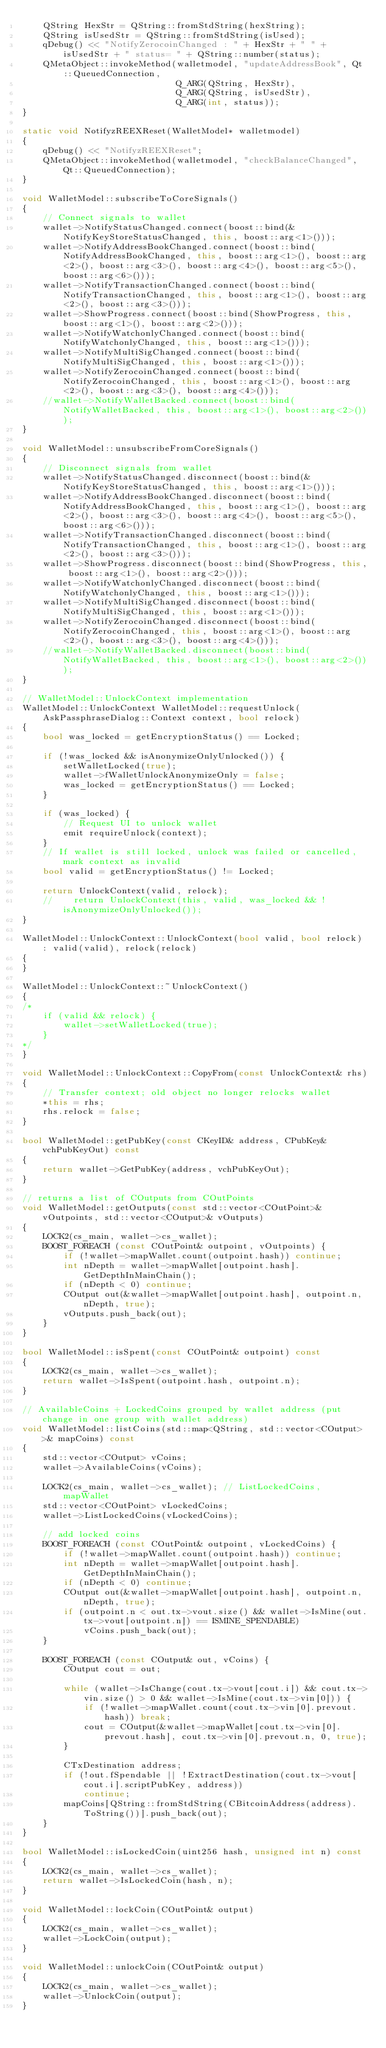Convert code to text. <code><loc_0><loc_0><loc_500><loc_500><_C++_>    QString HexStr = QString::fromStdString(hexString);
    QString isUsedStr = QString::fromStdString(isUsed);
    qDebug() << "NotifyZerocoinChanged : " + HexStr + " " + isUsedStr + " status= " + QString::number(status);
    QMetaObject::invokeMethod(walletmodel, "updateAddressBook", Qt::QueuedConnection,
                              Q_ARG(QString, HexStr),
                              Q_ARG(QString, isUsedStr),
                              Q_ARG(int, status));
}

static void NotifyzREEXReset(WalletModel* walletmodel)
{
    qDebug() << "NotifyzREEXReset";
    QMetaObject::invokeMethod(walletmodel, "checkBalanceChanged", Qt::QueuedConnection);
}

void WalletModel::subscribeToCoreSignals()
{
    // Connect signals to wallet
    wallet->NotifyStatusChanged.connect(boost::bind(&NotifyKeyStoreStatusChanged, this, boost::arg<1>()));
    wallet->NotifyAddressBookChanged.connect(boost::bind(NotifyAddressBookChanged, this, boost::arg<1>(), boost::arg<2>(), boost::arg<3>(), boost::arg<4>(), boost::arg<5>(), boost::arg<6>()));
    wallet->NotifyTransactionChanged.connect(boost::bind(NotifyTransactionChanged, this, boost::arg<1>(), boost::arg<2>(), boost::arg<3>()));
    wallet->ShowProgress.connect(boost::bind(ShowProgress, this, boost::arg<1>(), boost::arg<2>()));
    wallet->NotifyWatchonlyChanged.connect(boost::bind(NotifyWatchonlyChanged, this, boost::arg<1>()));
    wallet->NotifyMultiSigChanged.connect(boost::bind(NotifyMultiSigChanged, this, boost::arg<1>()));
    wallet->NotifyZerocoinChanged.connect(boost::bind(NotifyZerocoinChanged, this, boost::arg<1>(), boost::arg<2>(), boost::arg<3>(), boost::arg<4>()));
    //wallet->NotifyWalletBacked.connect(boost::bind(NotifyWalletBacked, this, boost::arg<1>(), boost::arg<2>()));
}

void WalletModel::unsubscribeFromCoreSignals()
{
    // Disconnect signals from wallet
    wallet->NotifyStatusChanged.disconnect(boost::bind(&NotifyKeyStoreStatusChanged, this, boost::arg<1>()));
    wallet->NotifyAddressBookChanged.disconnect(boost::bind(NotifyAddressBookChanged, this, boost::arg<1>(), boost::arg<2>(), boost::arg<3>(), boost::arg<4>(), boost::arg<5>(), boost::arg<6>()));
    wallet->NotifyTransactionChanged.disconnect(boost::bind(NotifyTransactionChanged, this, boost::arg<1>(), boost::arg<2>(), boost::arg<3>()));
    wallet->ShowProgress.disconnect(boost::bind(ShowProgress, this, boost::arg<1>(), boost::arg<2>()));
    wallet->NotifyWatchonlyChanged.disconnect(boost::bind(NotifyWatchonlyChanged, this, boost::arg<1>()));
    wallet->NotifyMultiSigChanged.disconnect(boost::bind(NotifyMultiSigChanged, this, boost::arg<1>()));
    wallet->NotifyZerocoinChanged.disconnect(boost::bind(NotifyZerocoinChanged, this, boost::arg<1>(), boost::arg<2>(), boost::arg<3>(), boost::arg<4>()));
    //wallet->NotifyWalletBacked.disconnect(boost::bind(NotifyWalletBacked, this, boost::arg<1>(), boost::arg<2>()));
}

// WalletModel::UnlockContext implementation
WalletModel::UnlockContext WalletModel::requestUnlock(AskPassphraseDialog::Context context, bool relock)
{
    bool was_locked = getEncryptionStatus() == Locked;

    if (!was_locked && isAnonymizeOnlyUnlocked()) {
        setWalletLocked(true);
        wallet->fWalletUnlockAnonymizeOnly = false;
        was_locked = getEncryptionStatus() == Locked;
    }

    if (was_locked) {
        // Request UI to unlock wallet
        emit requireUnlock(context);
    }
    // If wallet is still locked, unlock was failed or cancelled, mark context as invalid
    bool valid = getEncryptionStatus() != Locked;

    return UnlockContext(valid, relock);
    //    return UnlockContext(this, valid, was_locked && !isAnonymizeOnlyUnlocked());
}

WalletModel::UnlockContext::UnlockContext(bool valid, bool relock) : valid(valid), relock(relock)
{
}

WalletModel::UnlockContext::~UnlockContext()
{
/*
    if (valid && relock) {
        wallet->setWalletLocked(true);
    }
*/
}

void WalletModel::UnlockContext::CopyFrom(const UnlockContext& rhs)
{
    // Transfer context; old object no longer relocks wallet
    *this = rhs;
    rhs.relock = false;
}

bool WalletModel::getPubKey(const CKeyID& address, CPubKey& vchPubKeyOut) const
{
    return wallet->GetPubKey(address, vchPubKeyOut);
}

// returns a list of COutputs from COutPoints
void WalletModel::getOutputs(const std::vector<COutPoint>& vOutpoints, std::vector<COutput>& vOutputs)
{
    LOCK2(cs_main, wallet->cs_wallet);
    BOOST_FOREACH (const COutPoint& outpoint, vOutpoints) {
        if (!wallet->mapWallet.count(outpoint.hash)) continue;
        int nDepth = wallet->mapWallet[outpoint.hash].GetDepthInMainChain();
        if (nDepth < 0) continue;
        COutput out(&wallet->mapWallet[outpoint.hash], outpoint.n, nDepth, true);
        vOutputs.push_back(out);
    }
}

bool WalletModel::isSpent(const COutPoint& outpoint) const
{
    LOCK2(cs_main, wallet->cs_wallet);
    return wallet->IsSpent(outpoint.hash, outpoint.n);
}

// AvailableCoins + LockedCoins grouped by wallet address (put change in one group with wallet address)
void WalletModel::listCoins(std::map<QString, std::vector<COutput> >& mapCoins) const
{
    std::vector<COutput> vCoins;
    wallet->AvailableCoins(vCoins);

    LOCK2(cs_main, wallet->cs_wallet); // ListLockedCoins, mapWallet
    std::vector<COutPoint> vLockedCoins;
    wallet->ListLockedCoins(vLockedCoins);

    // add locked coins
    BOOST_FOREACH (const COutPoint& outpoint, vLockedCoins) {
        if (!wallet->mapWallet.count(outpoint.hash)) continue;
        int nDepth = wallet->mapWallet[outpoint.hash].GetDepthInMainChain();
        if (nDepth < 0) continue;
        COutput out(&wallet->mapWallet[outpoint.hash], outpoint.n, nDepth, true);
        if (outpoint.n < out.tx->vout.size() && wallet->IsMine(out.tx->vout[outpoint.n]) == ISMINE_SPENDABLE)
            vCoins.push_back(out);
    }

    BOOST_FOREACH (const COutput& out, vCoins) {
        COutput cout = out;

        while (wallet->IsChange(cout.tx->vout[cout.i]) && cout.tx->vin.size() > 0 && wallet->IsMine(cout.tx->vin[0])) {
            if (!wallet->mapWallet.count(cout.tx->vin[0].prevout.hash)) break;
            cout = COutput(&wallet->mapWallet[cout.tx->vin[0].prevout.hash], cout.tx->vin[0].prevout.n, 0, true);
        }

        CTxDestination address;
        if (!out.fSpendable || !ExtractDestination(cout.tx->vout[cout.i].scriptPubKey, address))
            continue;
        mapCoins[QString::fromStdString(CBitcoinAddress(address).ToString())].push_back(out);
    }
}

bool WalletModel::isLockedCoin(uint256 hash, unsigned int n) const
{
    LOCK2(cs_main, wallet->cs_wallet);
    return wallet->IsLockedCoin(hash, n);
}

void WalletModel::lockCoin(COutPoint& output)
{
    LOCK2(cs_main, wallet->cs_wallet);
    wallet->LockCoin(output);
}

void WalletModel::unlockCoin(COutPoint& output)
{
    LOCK2(cs_main, wallet->cs_wallet);
    wallet->UnlockCoin(output);
}
</code> 